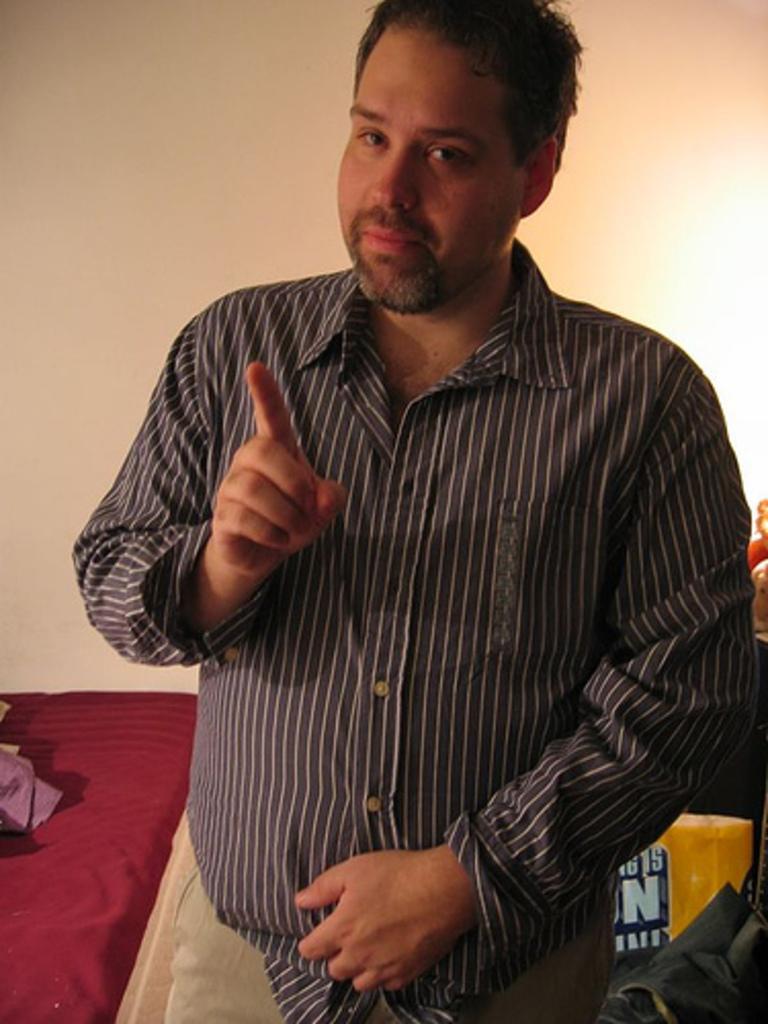Could you give a brief overview of what you see in this image? As we can see in the image there is a white color wall, bed and a man standing in the front. 